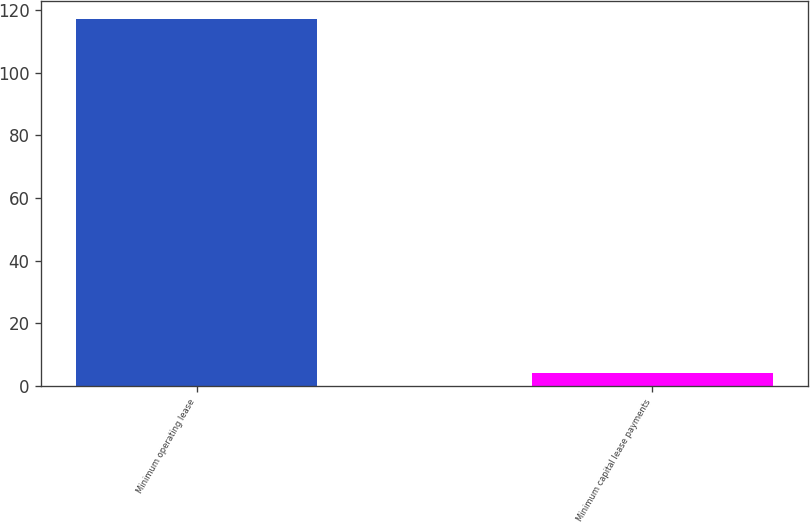Convert chart to OTSL. <chart><loc_0><loc_0><loc_500><loc_500><bar_chart><fcel>Minimum operating lease<fcel>Minimum capital lease payments<nl><fcel>117<fcel>4<nl></chart> 